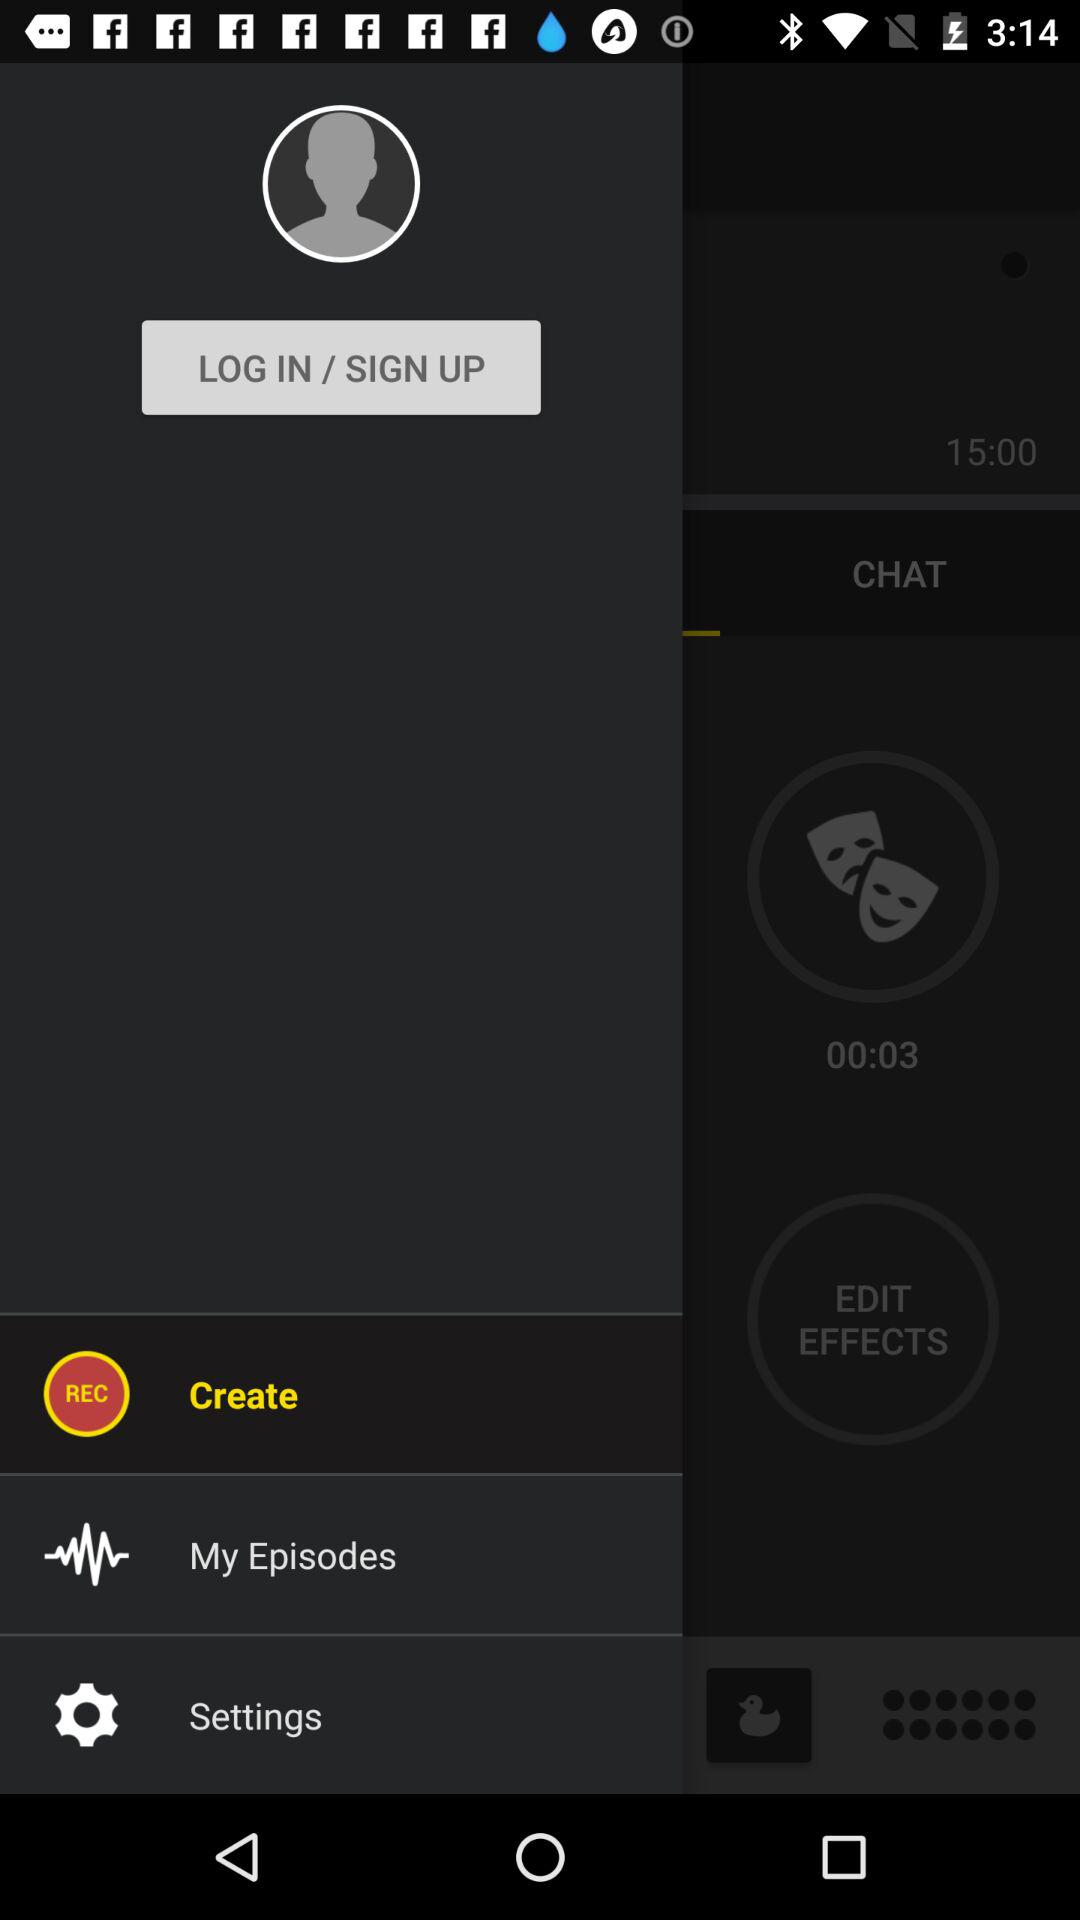Which item is selected? The selected item is "Create". 